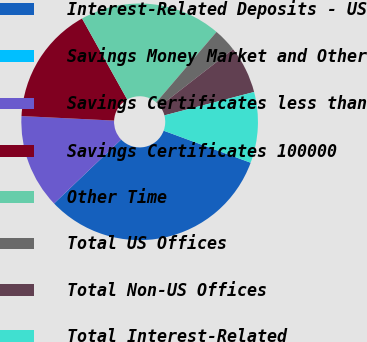Convert chart. <chart><loc_0><loc_0><loc_500><loc_500><pie_chart><fcel>Interest-Related Deposits - US<fcel>Savings Money Market and Other<fcel>Savings Certificates less than<fcel>Savings Certificates 100000<fcel>Other Time<fcel>Total US Offices<fcel>Total Non-US Offices<fcel>Total Interest-Related<nl><fcel>32.26%<fcel>0.0%<fcel>12.9%<fcel>16.13%<fcel>19.35%<fcel>3.23%<fcel>6.45%<fcel>9.68%<nl></chart> 